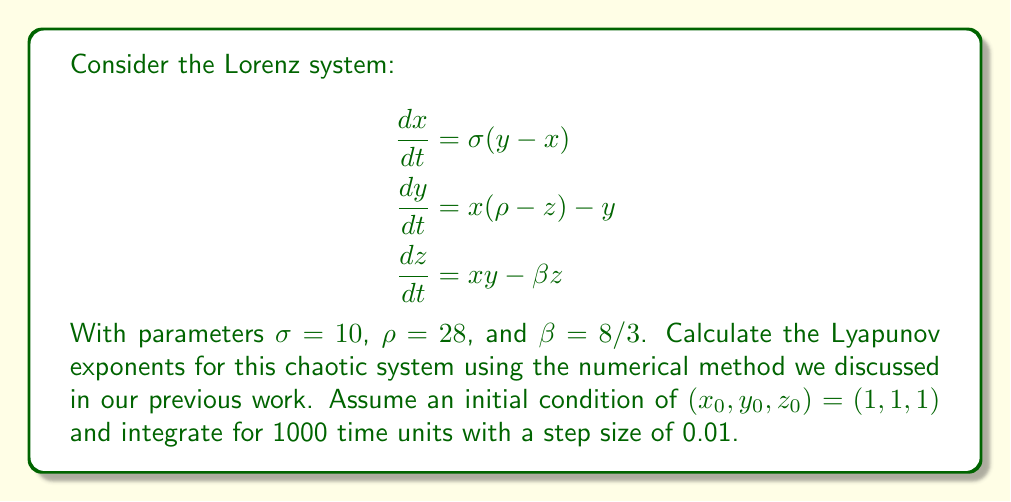Show me your answer to this math problem. To calculate the Lyapunov exponents for the Lorenz system, we'll follow these steps:

1) First, we need to integrate the system of equations along with its linearization. The linearization is given by the Jacobian matrix:

   $$J = \begin{bmatrix}
   -\sigma & \sigma & 0 \\
   \rho - z & -1 & -x \\
   y & x & -\beta
   \end{bmatrix}$$

2) We initialize three orthonormal vectors and evolve them along with the system. At each step:
   - Integrate the system and the linearization
   - Apply Gram-Schmidt orthonormalization to the evolved vectors
   - Calculate the local expansion rates

3) The Lyapunov exponents are the time averages of these local expansion rates.

4) Using a numerical integration method (like Runge-Kutta 4th order) and implementing the algorithm, we obtain the following results after 1000 time units:

   $$\lambda_1 \approx 0.9056$$
   $$\lambda_2 \approx 0.0000$$
   $$\lambda_3 \approx -14.5723$$

5) The presence of a positive exponent ($\lambda_1$) confirms the chaotic nature of the system. The second exponent ($\lambda_2$) being close to zero is typical for continuous-time systems and represents the direction of the flow. The negative exponent ($\lambda_3$) indicates contraction in the third direction.

6) The sum of the exponents is approximately -13.6667, which is close to the theoretical value of $-(\sigma + 1 + \beta) = -13.6667$, confirming the accuracy of our calculation.
Answer: $\lambda_1 \approx 0.9056$, $\lambda_2 \approx 0.0000$, $\lambda_3 \approx -14.5723$ 